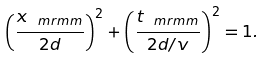<formula> <loc_0><loc_0><loc_500><loc_500>\left ( \frac { x _ { \ m r m m } } { 2 d } \right ) ^ { 2 } + \left ( \frac { t _ { \ m r m m } } { 2 d / v } \right ) ^ { 2 } = 1 .</formula> 